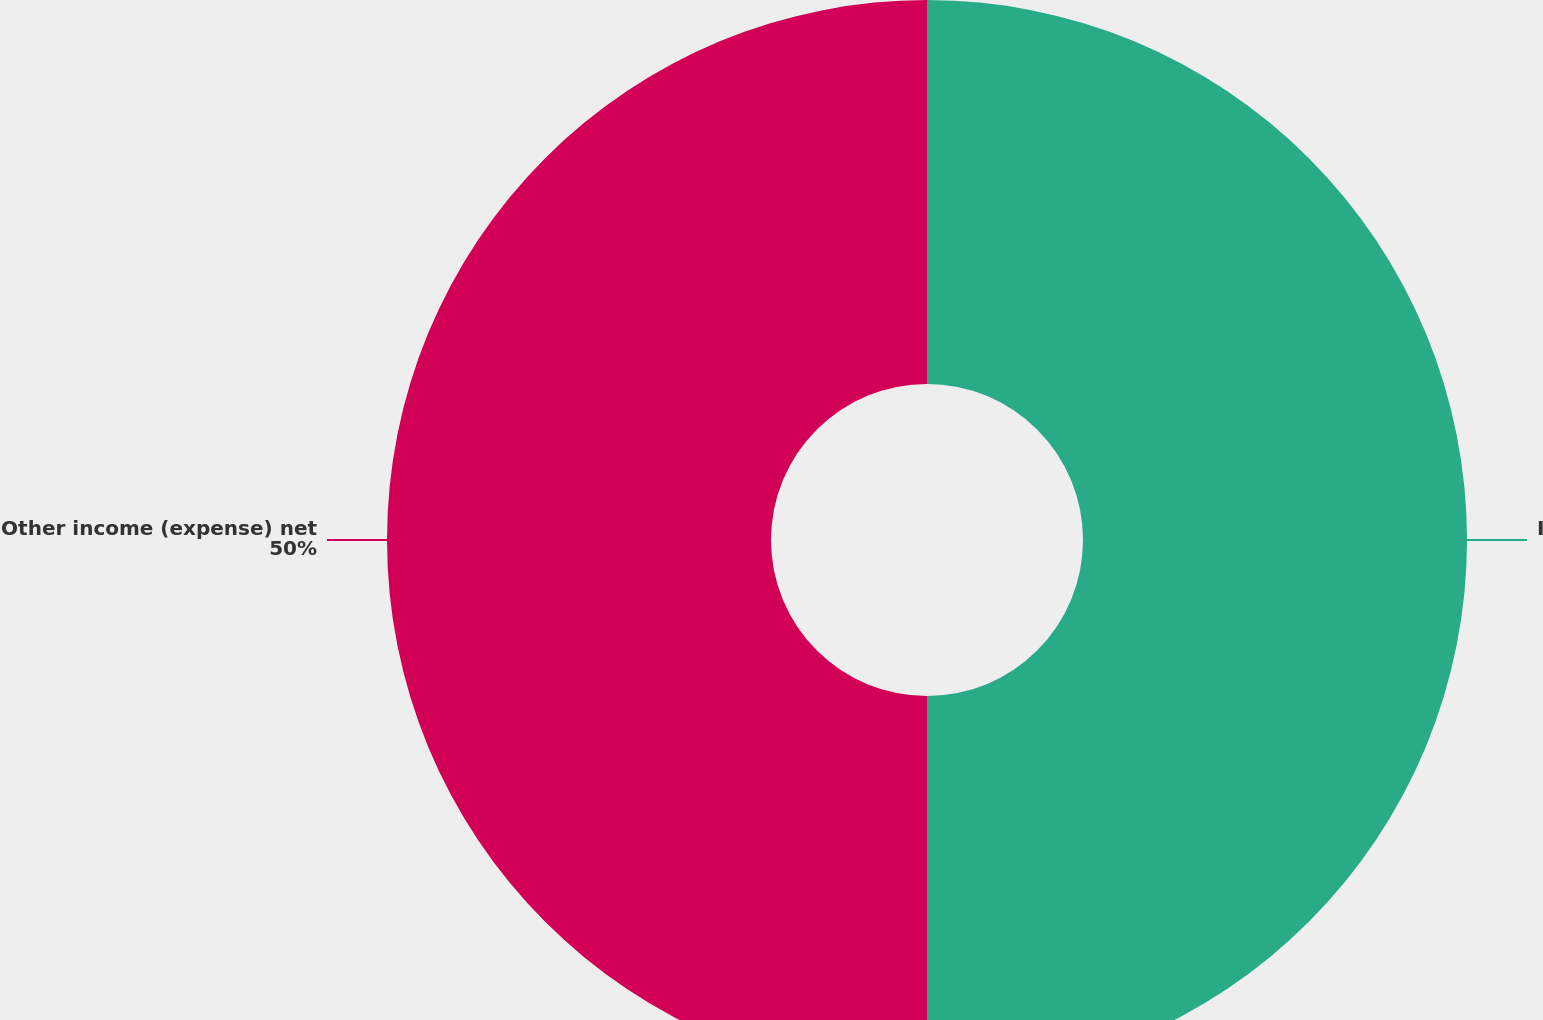Convert chart. <chart><loc_0><loc_0><loc_500><loc_500><pie_chart><fcel>Increase (reduction) to cost<fcel>Other income (expense) net<nl><fcel>50.0%<fcel>50.0%<nl></chart> 